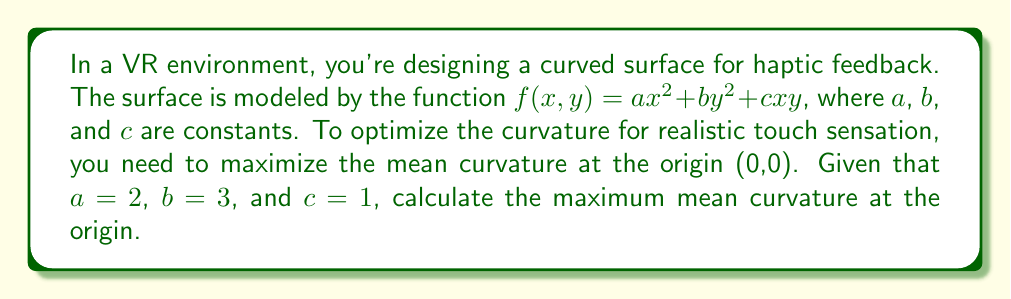What is the answer to this math problem? To solve this problem, we'll follow these steps:

1) The mean curvature $H$ of a surface $z = f(x,y)$ at a point $(x,y)$ is given by:

   $$H = \frac{(1+f_y^2)f_{xx} - 2f_xf_yf_{xy} + (1+f_x^2)f_{yy}}{2(1+f_x^2+f_y^2)^{3/2}}$$

   where $f_x$, $f_y$ are first partial derivatives and $f_{xx}$, $f_{xy}$, $f_{yy}$ are second partial derivatives.

2) For our surface $f(x,y) = ax^2 + by^2 + cxy$, we calculate:
   
   $f_x = 2ax + cy$
   $f_y = 2by + cx$
   $f_{xx} = 2a$
   $f_{yy} = 2b$
   $f_{xy} = c$

3) At the origin (0,0):
   
   $f_x(0,0) = f_y(0,0) = 0$
   $f_{xx}(0,0) = 2a = 4$
   $f_{yy}(0,0) = 2b = 6$
   $f_{xy}(0,0) = c = 1$

4) Substituting these values into the mean curvature formula:

   $$H = \frac{(1+0^2)4 - 2(0)(0)(1) + (1+0^2)6}{2(1+0^2+0^2)^{3/2}} = \frac{4+6}{2} = 5$$

5) Therefore, the maximum mean curvature at the origin is 5.
Answer: 5 